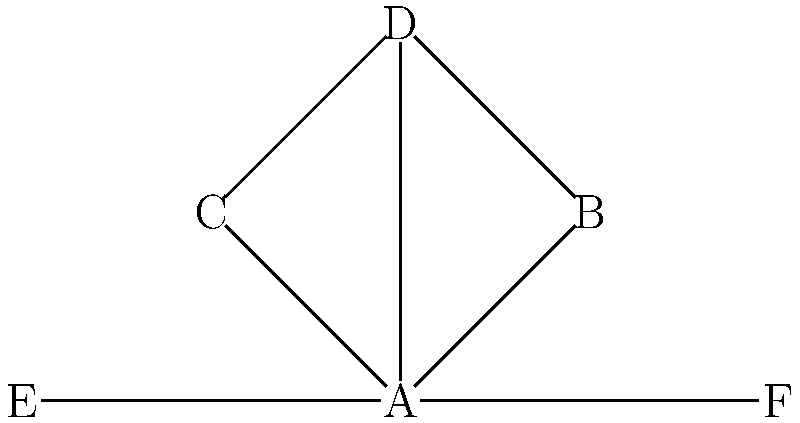In the given node-link diagram representing a social network structure in a non-western community, which node has the highest degree centrality? How might this information be useful in understanding the community's social dynamics? To answer this question, we need to follow these steps:

1. Understand degree centrality:
   Degree centrality is a measure of the number of direct connections a node has in a network.

2. Count the connections for each node:
   A: 5 connections (B, C, D, E, F)
   B: 2 connections (A, D)
   C: 2 connections (A, D)
   D: 3 connections (A, B, C)
   E: 1 connection (A)
   F: 1 connection (A)

3. Identify the node with the highest degree centrality:
   Node A has the highest degree centrality with 5 connections.

4. Interpret the results:
   In non-western communities, the node with the highest degree centrality (A in this case) might represent:
   - A community leader or elder
   - A central figure in information dissemination
   - A key person in resource distribution or decision-making

5. Understand the usefulness of this information:
   - Helps identify influential individuals in the community
   - Provides insights into power structures and social hierarchies
   - Aids in understanding information flow and resource distribution
   - Can be crucial for implementing community development programs or interventions

This analysis demonstrates how node-link diagrams can be valuable tools for studying social structures in non-western markets, allowing researchers to visualize and quantify social relationships and power dynamics.
Answer: Node A; identifies influential individuals, reveals power structures, and aids in understanding information flow and resource distribution. 